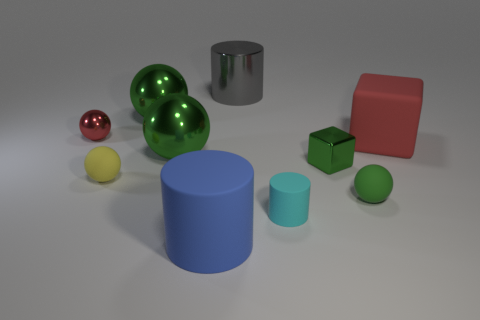Subtract 1 balls. How many balls are left? 4 Subtract all green blocks. How many green balls are left? 3 Subtract all red metallic spheres. How many spheres are left? 4 Subtract all red balls. How many balls are left? 4 Subtract all cyan spheres. Subtract all yellow cubes. How many spheres are left? 5 Subtract all blocks. How many objects are left? 8 Subtract all green blocks. Subtract all green cubes. How many objects are left? 8 Add 8 large red matte blocks. How many large red matte blocks are left? 9 Add 4 big gray cylinders. How many big gray cylinders exist? 5 Subtract 0 brown cylinders. How many objects are left? 10 